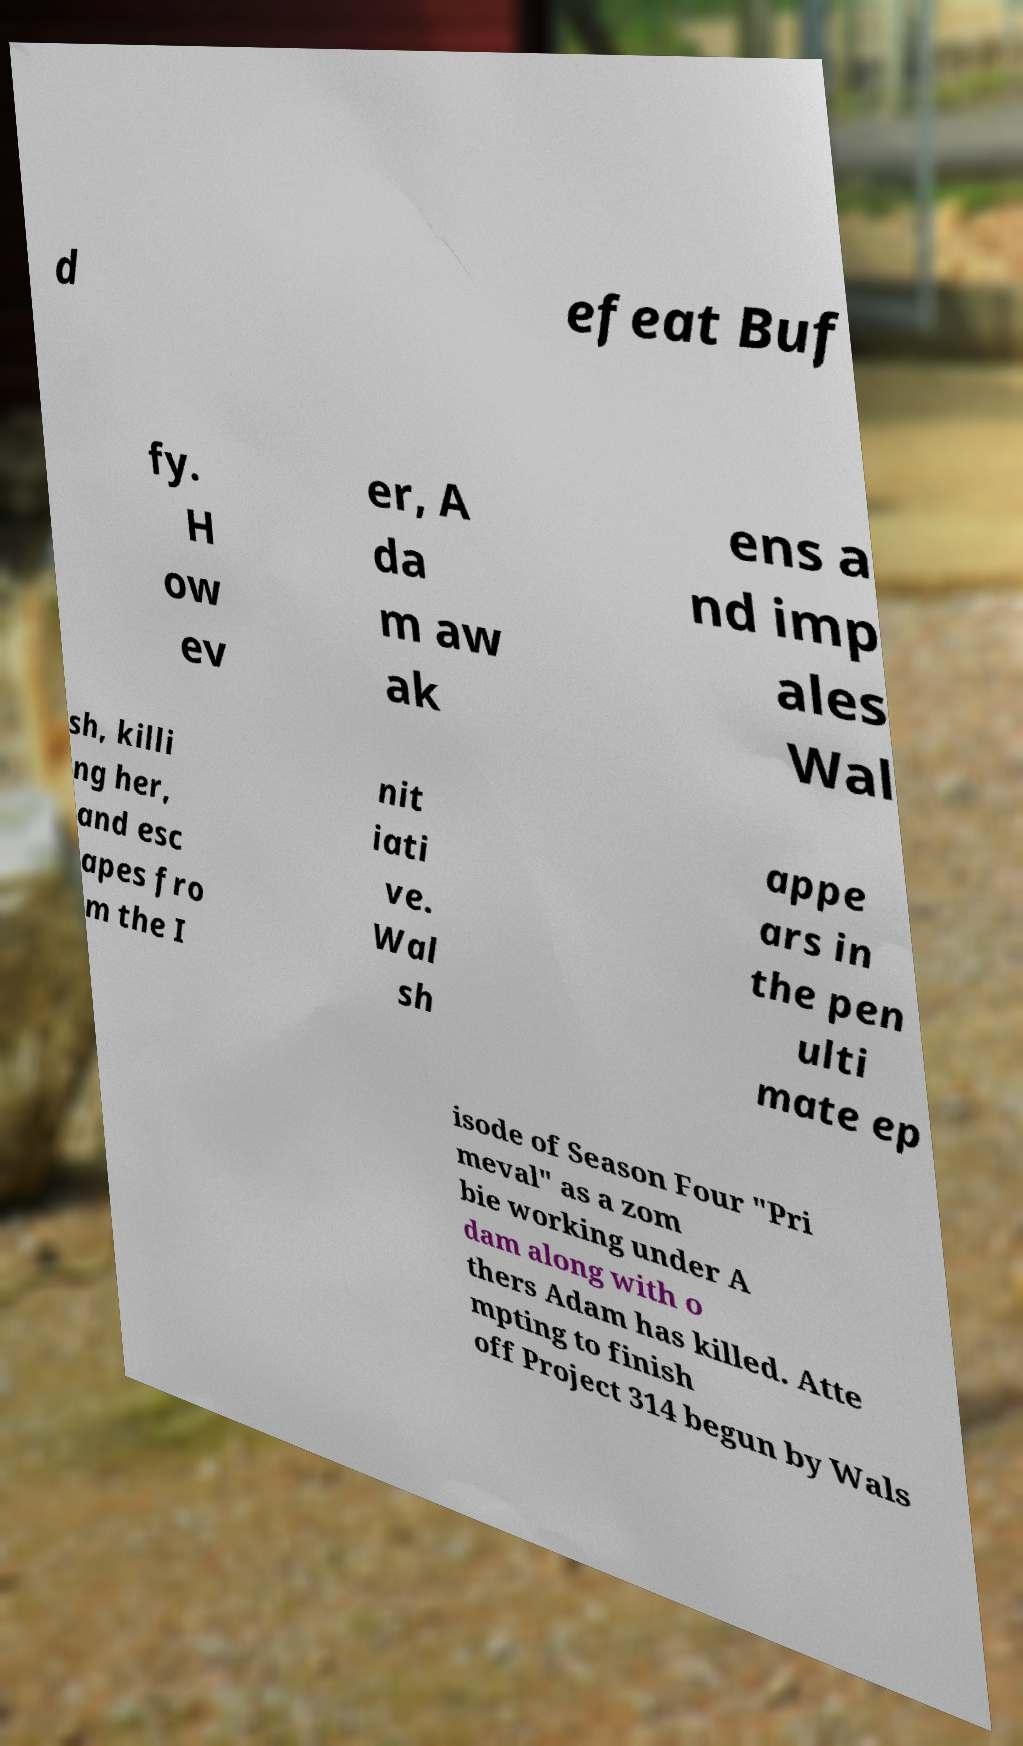What messages or text are displayed in this image? I need them in a readable, typed format. d efeat Buf fy. H ow ev er, A da m aw ak ens a nd imp ales Wal sh, killi ng her, and esc apes fro m the I nit iati ve. Wal sh appe ars in the pen ulti mate ep isode of Season Four "Pri meval" as a zom bie working under A dam along with o thers Adam has killed. Atte mpting to finish off Project 314 begun by Wals 